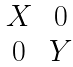Convert formula to latex. <formula><loc_0><loc_0><loc_500><loc_500>\begin{matrix} X & 0 \\ 0 & Y \\ \end{matrix}</formula> 